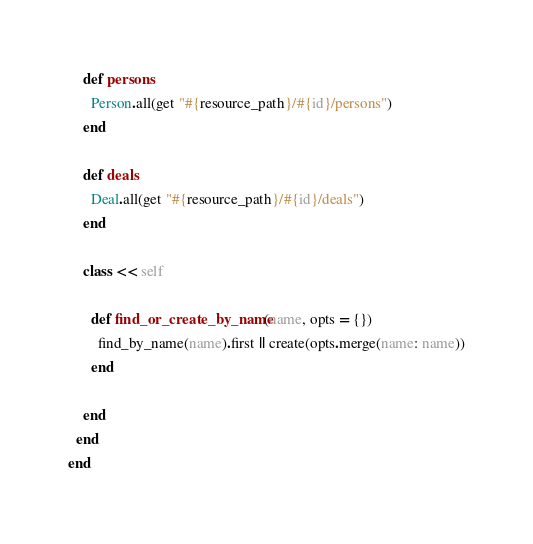Convert code to text. <code><loc_0><loc_0><loc_500><loc_500><_Ruby_>    def persons
      Person.all(get "#{resource_path}/#{id}/persons")
    end

    def deals
      Deal.all(get "#{resource_path}/#{id}/deals")
    end

    class << self

      def find_or_create_by_name(name, opts = {})
        find_by_name(name).first || create(opts.merge(name: name))
      end

    end
  end
end
</code> 